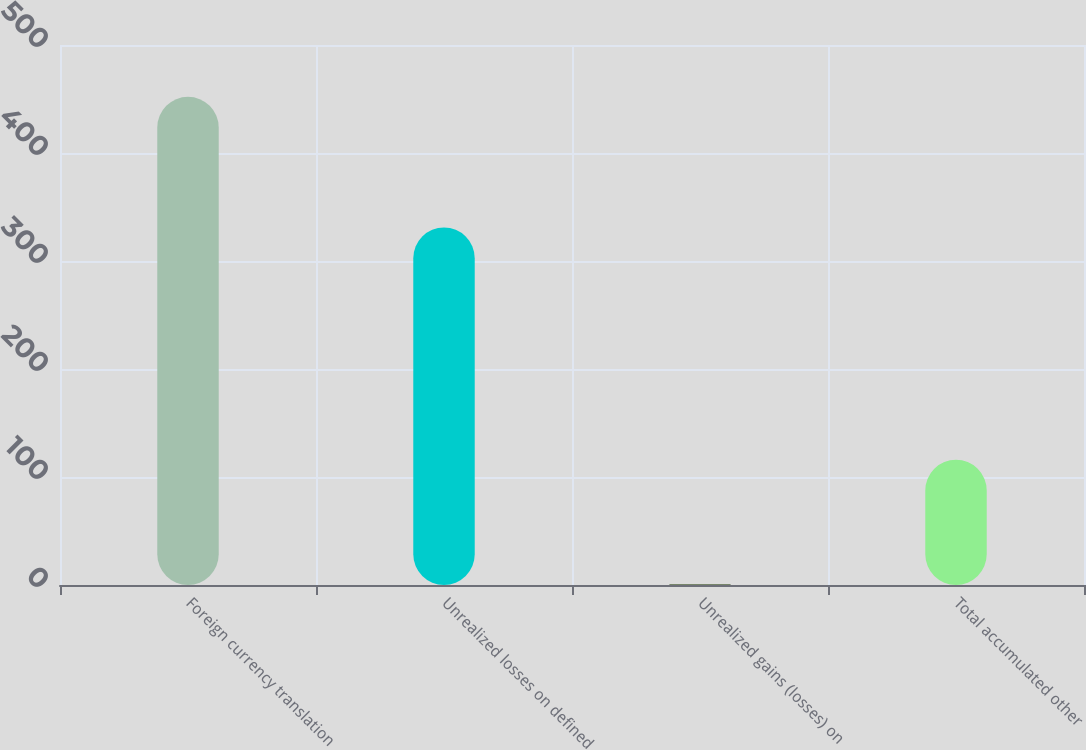Convert chart to OTSL. <chart><loc_0><loc_0><loc_500><loc_500><bar_chart><fcel>Foreign currency translation<fcel>Unrealized losses on defined<fcel>Unrealized gains (losses) on<fcel>Total accumulated other<nl><fcel>452<fcel>331<fcel>1<fcel>116<nl></chart> 